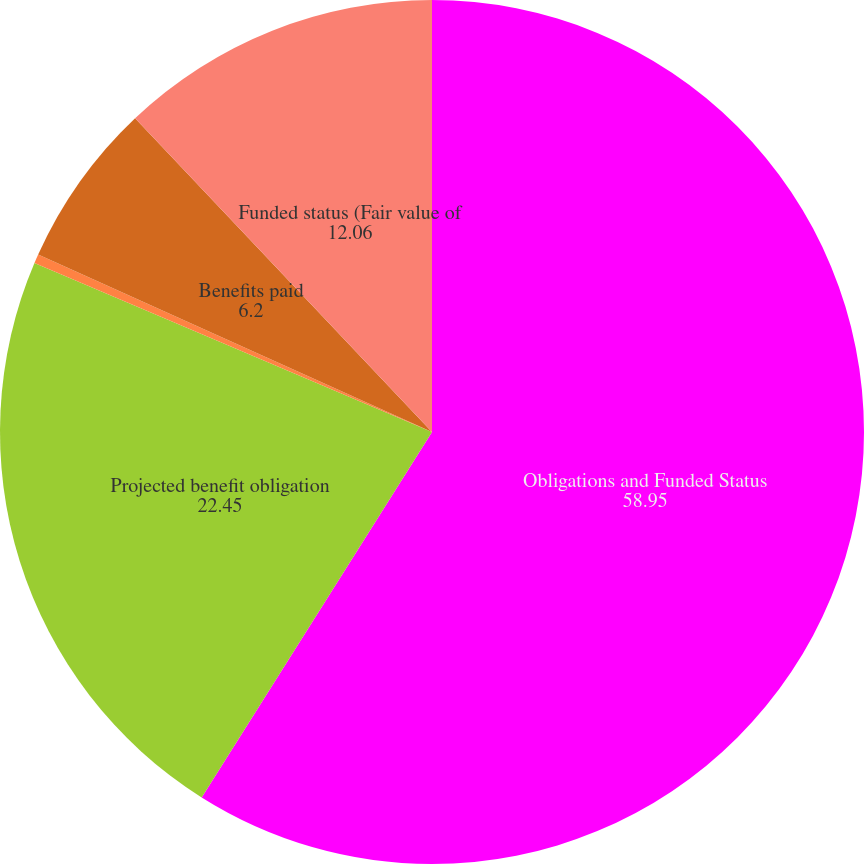Convert chart. <chart><loc_0><loc_0><loc_500><loc_500><pie_chart><fcel>Obligations and Funded Status<fcel>Projected benefit obligation<fcel>Actuarial loss (gain)<fcel>Benefits paid<fcel>Funded status (Fair value of<nl><fcel>58.95%<fcel>22.45%<fcel>0.34%<fcel>6.2%<fcel>12.06%<nl></chart> 